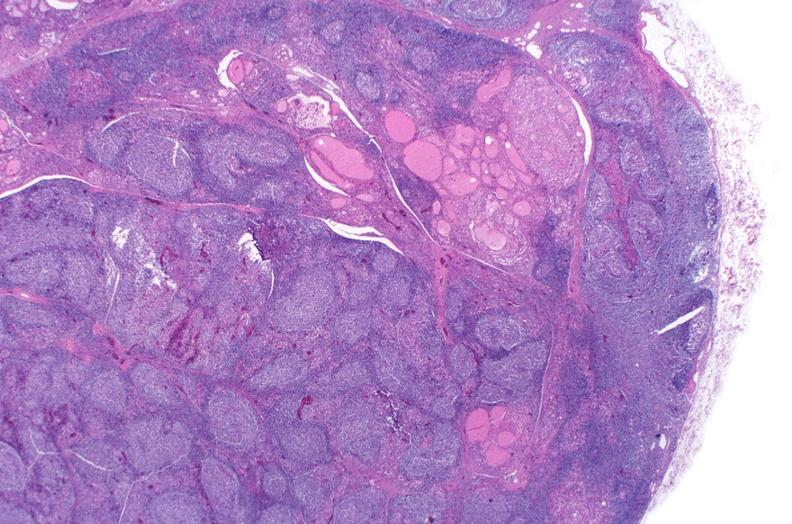where is this part in the figure?
Answer the question using a single word or phrase. Endocrine system 